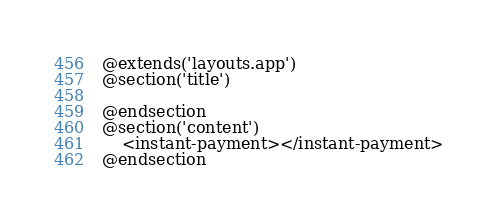<code> <loc_0><loc_0><loc_500><loc_500><_PHP_>@extends('layouts.app')
@section('title')

@endsection
@section('content')
    <instant-payment></instant-payment>
@endsection
</code> 